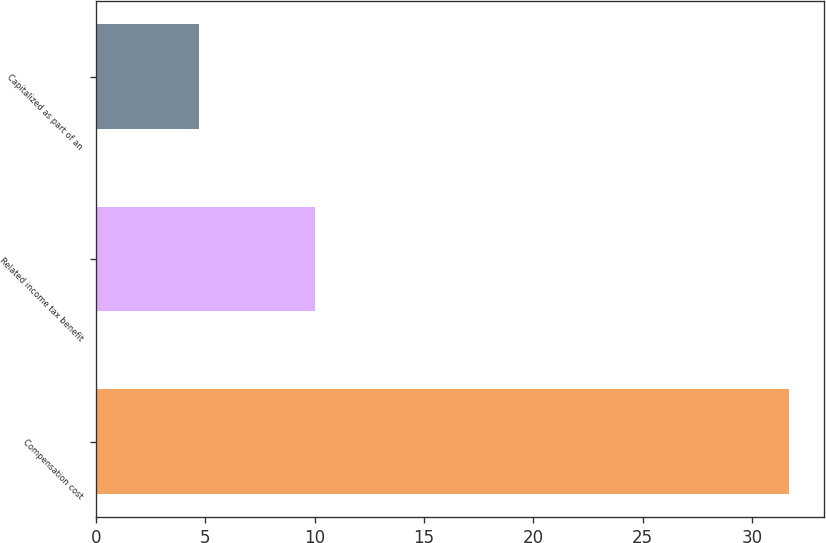Convert chart to OTSL. <chart><loc_0><loc_0><loc_500><loc_500><bar_chart><fcel>Compensation cost<fcel>Related income tax benefit<fcel>Capitalized as part of an<nl><fcel>31.7<fcel>10<fcel>4.7<nl></chart> 